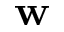Convert formula to latex. <formula><loc_0><loc_0><loc_500><loc_500>w</formula> 